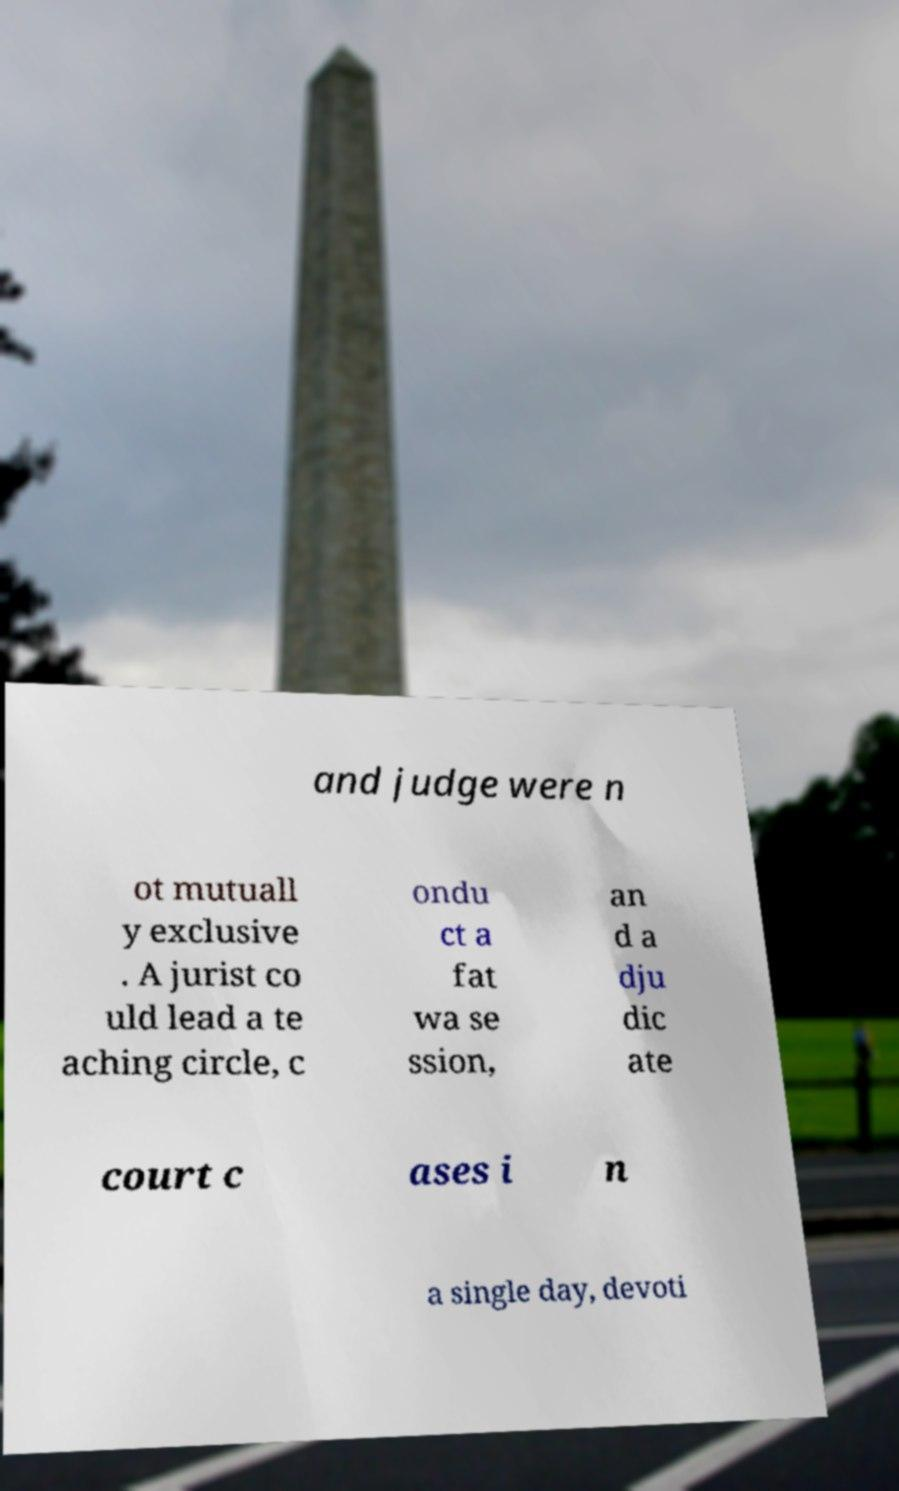Can you accurately transcribe the text from the provided image for me? and judge were n ot mutuall y exclusive . A jurist co uld lead a te aching circle, c ondu ct a fat wa se ssion, an d a dju dic ate court c ases i n a single day, devoti 